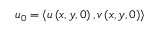<formula> <loc_0><loc_0><loc_500><loc_500>u _ { 0 } = \left < u \left ( x , y , 0 \right ) , v \left ( x , y , 0 \right ) \right ></formula> 